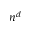Convert formula to latex. <formula><loc_0><loc_0><loc_500><loc_500>n ^ { d }</formula> 